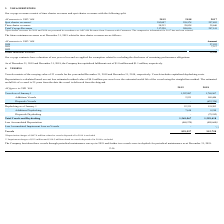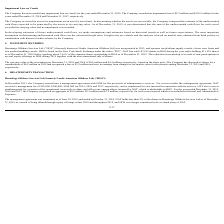From Nordic American Tankers Limited's financial document, What are the respective values excluded from the Accumulated Impairment Loss on Vessels? The document shows two values: Impairment charges of $2.2 million and $110.5 million related to vessels disposed of in 2018. From the document: "** Impairment charges of $2.2 million and $110.5 million related to vessels disposed of in 2018 is excluded ** Impairment charges of $2.2 million and ..." Also, What is excluded from the accumulated depreciation of vessels in 2018? Depreciation charges of $497.0 million related to vessels disposed of in 2018. The document states: "*Depreciation charges of $497.0 million related to vessels disposed of in 2018 is excluded..." Also, What are the respective values of vessels as of January 1, 2018 and 2019? The document shows two values: 1,769,967 and 1,307,087. From the document: "Vessels as of January 1 1,307,087 1,769,967 Vessels as of January 1 1,307,087 1,769,967..." Also, can you calculate: What is the percentage change in the value of vessels between January 1, 2018 and 2019? To answer this question, I need to perform calculations using the financial data. The calculation is: (1,307,087 - 1,769,967)/1,769,967 , which equals -26.15 (percentage). This is based on the information: "Vessels as of January 1 1,307,087 1,769,967 Vessels as of January 1 1,307,087 1,769,967..." The key data points involved are: 1,307,087, 1,769,967. Also, can you calculate: What is the average value of additional vessels added in 2018 and 2019? To answer this question, I need to perform calculations using the financial data. The calculation is: (169,446 + 2,531)/2 , which equals 85988.5 (in thousands). This is based on the information: "Additions Vessels 2,531 169,446 Additions Vessels 2,531 169,446..." The key data points involved are: 169,446, 2,531. Also, can you calculate: What is the percentage change in the value of vessel additions between 2018 and 2019? To answer this question, I need to perform calculations using the financial data. The calculation is: (2,531 - 169,446)/169,446 , which equals -98.51 (percentage). This is based on the information: "Additions Vessels 2,531 169,446 Additions Vessels 2,531 169,446..." The key data points involved are: 169,446, 2,531. 